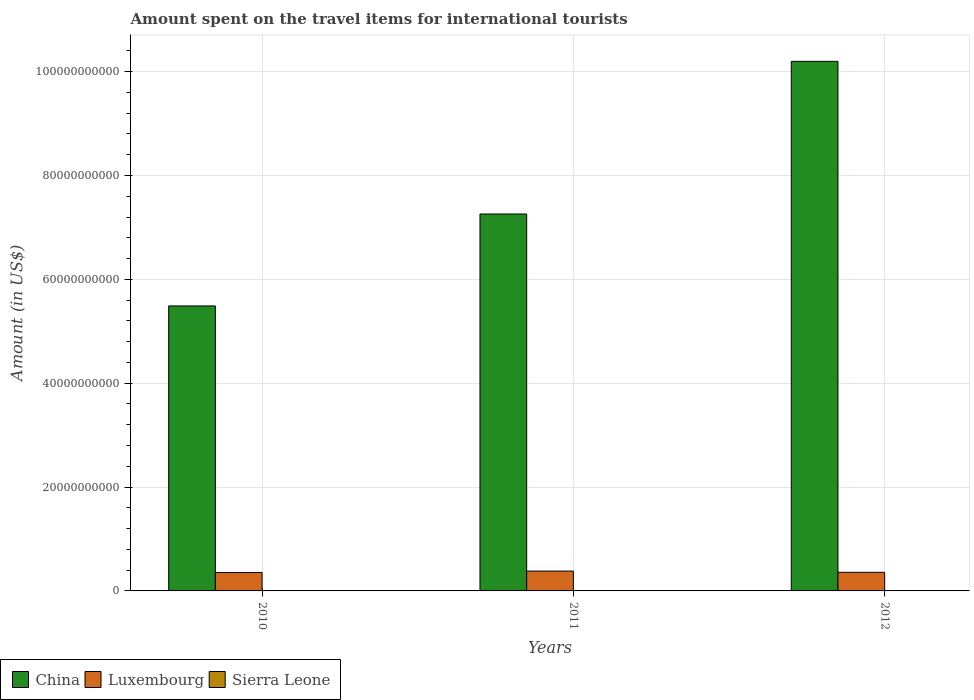Are the number of bars on each tick of the X-axis equal?
Offer a terse response. Yes. How many bars are there on the 3rd tick from the left?
Provide a succinct answer. 3. In how many cases, is the number of bars for a given year not equal to the number of legend labels?
Provide a short and direct response. 0. What is the amount spent on the travel items for international tourists in Luxembourg in 2012?
Give a very brief answer. 3.58e+09. Across all years, what is the maximum amount spent on the travel items for international tourists in Luxembourg?
Provide a succinct answer. 3.82e+09. Across all years, what is the minimum amount spent on the travel items for international tourists in China?
Give a very brief answer. 5.49e+1. What is the total amount spent on the travel items for international tourists in China in the graph?
Your answer should be compact. 2.29e+11. What is the difference between the amount spent on the travel items for international tourists in China in 2010 and that in 2012?
Give a very brief answer. -4.71e+1. What is the difference between the amount spent on the travel items for international tourists in Sierra Leone in 2010 and the amount spent on the travel items for international tourists in Luxembourg in 2012?
Provide a succinct answer. -3.57e+09. What is the average amount spent on the travel items for international tourists in Sierra Leone per year?
Keep it short and to the point. 1.40e+07. In the year 2011, what is the difference between the amount spent on the travel items for international tourists in Sierra Leone and amount spent on the travel items for international tourists in China?
Offer a terse response. -7.26e+1. What is the ratio of the amount spent on the travel items for international tourists in China in 2010 to that in 2011?
Offer a very short reply. 0.76. Is the amount spent on the travel items for international tourists in Sierra Leone in 2010 less than that in 2012?
Provide a succinct answer. Yes. Is the difference between the amount spent on the travel items for international tourists in Sierra Leone in 2011 and 2012 greater than the difference between the amount spent on the travel items for international tourists in China in 2011 and 2012?
Provide a short and direct response. Yes. What is the difference between the highest and the lowest amount spent on the travel items for international tourists in China?
Provide a short and direct response. 4.71e+1. Is the sum of the amount spent on the travel items for international tourists in Luxembourg in 2010 and 2011 greater than the maximum amount spent on the travel items for international tourists in Sierra Leone across all years?
Your response must be concise. Yes. What does the 3rd bar from the left in 2011 represents?
Your response must be concise. Sierra Leone. Are all the bars in the graph horizontal?
Your answer should be compact. No. How many years are there in the graph?
Your answer should be very brief. 3. Are the values on the major ticks of Y-axis written in scientific E-notation?
Provide a succinct answer. No. Where does the legend appear in the graph?
Ensure brevity in your answer.  Bottom left. What is the title of the graph?
Provide a succinct answer. Amount spent on the travel items for international tourists. What is the label or title of the Y-axis?
Ensure brevity in your answer.  Amount (in US$). What is the Amount (in US$) in China in 2010?
Provide a succinct answer. 5.49e+1. What is the Amount (in US$) of Luxembourg in 2010?
Make the answer very short. 3.55e+09. What is the Amount (in US$) of Sierra Leone in 2010?
Make the answer very short. 1.30e+07. What is the Amount (in US$) in China in 2011?
Offer a terse response. 7.26e+1. What is the Amount (in US$) of Luxembourg in 2011?
Make the answer very short. 3.82e+09. What is the Amount (in US$) in Sierra Leone in 2011?
Your answer should be compact. 1.40e+07. What is the Amount (in US$) of China in 2012?
Your answer should be very brief. 1.02e+11. What is the Amount (in US$) of Luxembourg in 2012?
Keep it short and to the point. 3.58e+09. What is the Amount (in US$) of Sierra Leone in 2012?
Your answer should be compact. 1.50e+07. Across all years, what is the maximum Amount (in US$) of China?
Offer a terse response. 1.02e+11. Across all years, what is the maximum Amount (in US$) in Luxembourg?
Your answer should be compact. 3.82e+09. Across all years, what is the maximum Amount (in US$) in Sierra Leone?
Your answer should be compact. 1.50e+07. Across all years, what is the minimum Amount (in US$) of China?
Offer a terse response. 5.49e+1. Across all years, what is the minimum Amount (in US$) of Luxembourg?
Offer a very short reply. 3.55e+09. Across all years, what is the minimum Amount (in US$) of Sierra Leone?
Make the answer very short. 1.30e+07. What is the total Amount (in US$) of China in the graph?
Offer a very short reply. 2.29e+11. What is the total Amount (in US$) of Luxembourg in the graph?
Give a very brief answer. 1.10e+1. What is the total Amount (in US$) of Sierra Leone in the graph?
Your answer should be compact. 4.20e+07. What is the difference between the Amount (in US$) in China in 2010 and that in 2011?
Make the answer very short. -1.77e+1. What is the difference between the Amount (in US$) of Luxembourg in 2010 and that in 2011?
Your answer should be compact. -2.73e+08. What is the difference between the Amount (in US$) in China in 2010 and that in 2012?
Offer a terse response. -4.71e+1. What is the difference between the Amount (in US$) of Luxembourg in 2010 and that in 2012?
Keep it short and to the point. -3.40e+07. What is the difference between the Amount (in US$) in China in 2011 and that in 2012?
Ensure brevity in your answer.  -2.94e+1. What is the difference between the Amount (in US$) in Luxembourg in 2011 and that in 2012?
Offer a very short reply. 2.39e+08. What is the difference between the Amount (in US$) of China in 2010 and the Amount (in US$) of Luxembourg in 2011?
Ensure brevity in your answer.  5.11e+1. What is the difference between the Amount (in US$) in China in 2010 and the Amount (in US$) in Sierra Leone in 2011?
Your response must be concise. 5.49e+1. What is the difference between the Amount (in US$) of Luxembourg in 2010 and the Amount (in US$) of Sierra Leone in 2011?
Offer a terse response. 3.54e+09. What is the difference between the Amount (in US$) of China in 2010 and the Amount (in US$) of Luxembourg in 2012?
Keep it short and to the point. 5.13e+1. What is the difference between the Amount (in US$) in China in 2010 and the Amount (in US$) in Sierra Leone in 2012?
Offer a terse response. 5.49e+1. What is the difference between the Amount (in US$) of Luxembourg in 2010 and the Amount (in US$) of Sierra Leone in 2012?
Provide a succinct answer. 3.53e+09. What is the difference between the Amount (in US$) of China in 2011 and the Amount (in US$) of Luxembourg in 2012?
Provide a succinct answer. 6.90e+1. What is the difference between the Amount (in US$) in China in 2011 and the Amount (in US$) in Sierra Leone in 2012?
Give a very brief answer. 7.26e+1. What is the difference between the Amount (in US$) in Luxembourg in 2011 and the Amount (in US$) in Sierra Leone in 2012?
Make the answer very short. 3.81e+09. What is the average Amount (in US$) of China per year?
Keep it short and to the point. 7.65e+1. What is the average Amount (in US$) of Luxembourg per year?
Ensure brevity in your answer.  3.65e+09. What is the average Amount (in US$) of Sierra Leone per year?
Your answer should be very brief. 1.40e+07. In the year 2010, what is the difference between the Amount (in US$) of China and Amount (in US$) of Luxembourg?
Ensure brevity in your answer.  5.13e+1. In the year 2010, what is the difference between the Amount (in US$) of China and Amount (in US$) of Sierra Leone?
Provide a succinct answer. 5.49e+1. In the year 2010, what is the difference between the Amount (in US$) in Luxembourg and Amount (in US$) in Sierra Leone?
Offer a terse response. 3.54e+09. In the year 2011, what is the difference between the Amount (in US$) of China and Amount (in US$) of Luxembourg?
Keep it short and to the point. 6.88e+1. In the year 2011, what is the difference between the Amount (in US$) in China and Amount (in US$) in Sierra Leone?
Ensure brevity in your answer.  7.26e+1. In the year 2011, what is the difference between the Amount (in US$) in Luxembourg and Amount (in US$) in Sierra Leone?
Your response must be concise. 3.81e+09. In the year 2012, what is the difference between the Amount (in US$) of China and Amount (in US$) of Luxembourg?
Your answer should be compact. 9.84e+1. In the year 2012, what is the difference between the Amount (in US$) of China and Amount (in US$) of Sierra Leone?
Make the answer very short. 1.02e+11. In the year 2012, what is the difference between the Amount (in US$) in Luxembourg and Amount (in US$) in Sierra Leone?
Your response must be concise. 3.57e+09. What is the ratio of the Amount (in US$) in China in 2010 to that in 2011?
Offer a very short reply. 0.76. What is the ratio of the Amount (in US$) of China in 2010 to that in 2012?
Your response must be concise. 0.54. What is the ratio of the Amount (in US$) in Sierra Leone in 2010 to that in 2012?
Offer a terse response. 0.87. What is the ratio of the Amount (in US$) in China in 2011 to that in 2012?
Make the answer very short. 0.71. What is the ratio of the Amount (in US$) of Luxembourg in 2011 to that in 2012?
Give a very brief answer. 1.07. What is the ratio of the Amount (in US$) in Sierra Leone in 2011 to that in 2012?
Provide a short and direct response. 0.93. What is the difference between the highest and the second highest Amount (in US$) of China?
Give a very brief answer. 2.94e+1. What is the difference between the highest and the second highest Amount (in US$) in Luxembourg?
Provide a succinct answer. 2.39e+08. What is the difference between the highest and the lowest Amount (in US$) of China?
Provide a short and direct response. 4.71e+1. What is the difference between the highest and the lowest Amount (in US$) of Luxembourg?
Ensure brevity in your answer.  2.73e+08. 